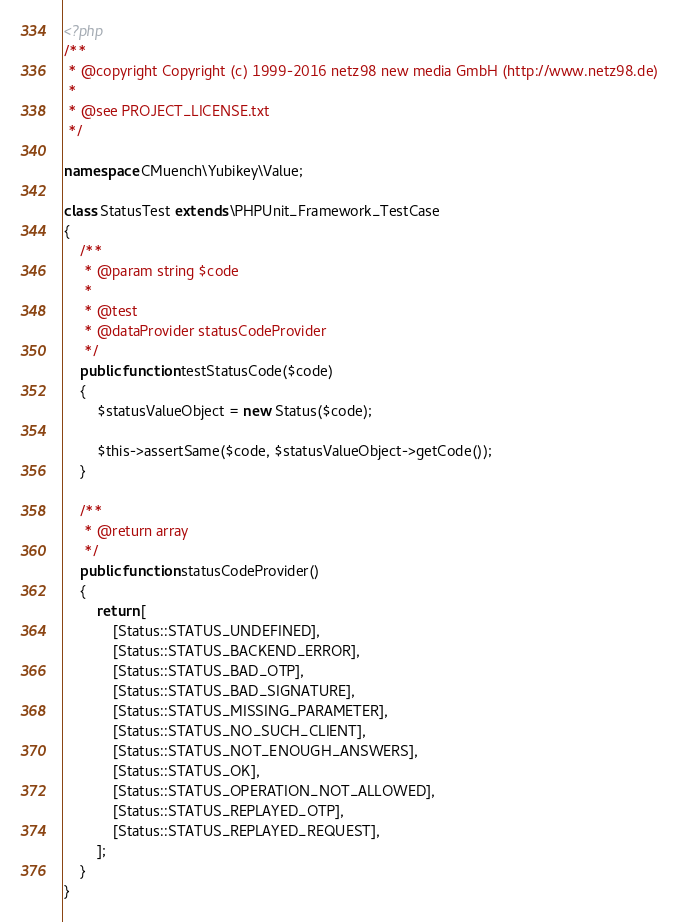Convert code to text. <code><loc_0><loc_0><loc_500><loc_500><_PHP_><?php
/**
 * @copyright Copyright (c) 1999-2016 netz98 new media GmbH (http://www.netz98.de)
 *
 * @see PROJECT_LICENSE.txt
 */

namespace CMuench\Yubikey\Value;

class StatusTest extends \PHPUnit_Framework_TestCase
{
    /**
     * @param string $code
     *
     * @test
     * @dataProvider statusCodeProvider
     */
    public function testStatusCode($code)
    {
        $statusValueObject = new Status($code);

        $this->assertSame($code, $statusValueObject->getCode());
    }

    /**
     * @return array
     */
    public function statusCodeProvider()
    {
        return [
            [Status::STATUS_UNDEFINED],
            [Status::STATUS_BACKEND_ERROR],
            [Status::STATUS_BAD_OTP],
            [Status::STATUS_BAD_SIGNATURE],
            [Status::STATUS_MISSING_PARAMETER],
            [Status::STATUS_NO_SUCH_CLIENT],
            [Status::STATUS_NOT_ENOUGH_ANSWERS],
            [Status::STATUS_OK],
            [Status::STATUS_OPERATION_NOT_ALLOWED],
            [Status::STATUS_REPLAYED_OTP],
            [Status::STATUS_REPLAYED_REQUEST],
        ];
    }
}
</code> 